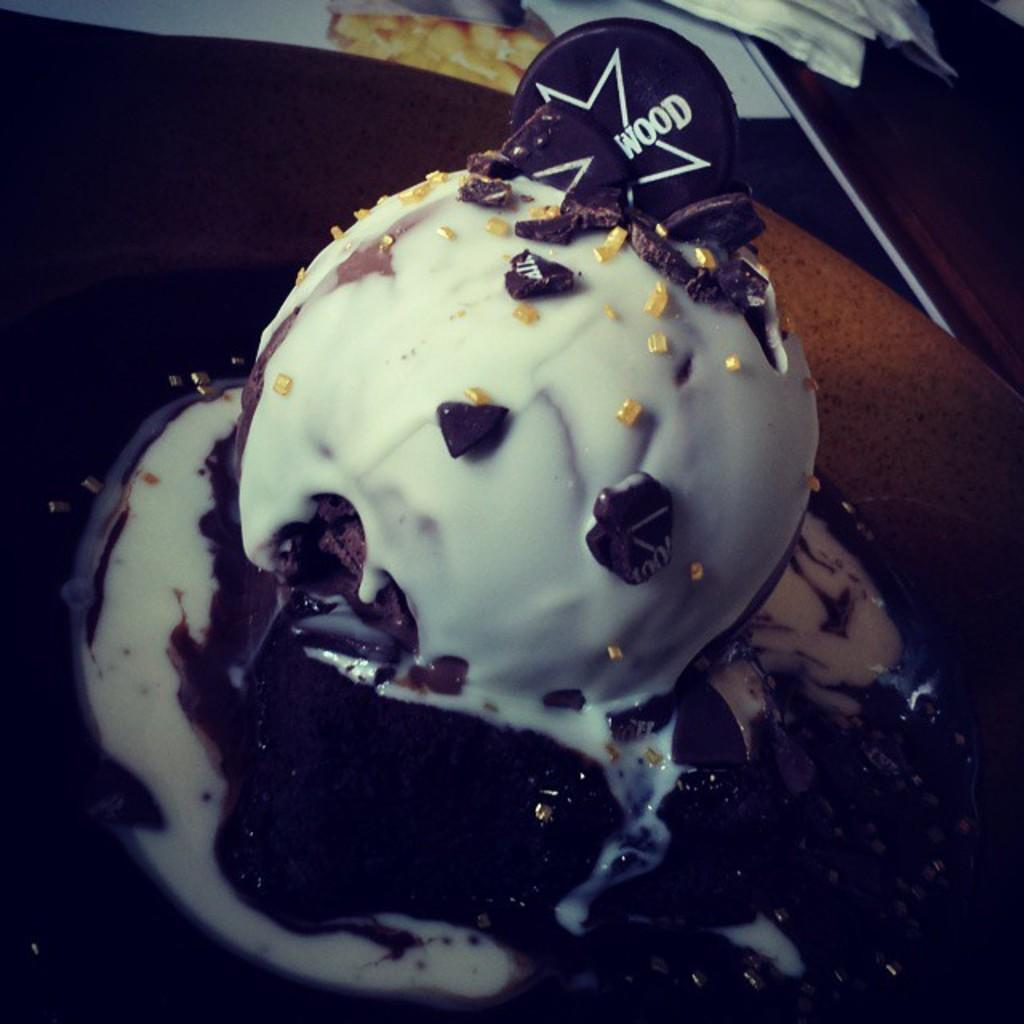What type of food item is visible in the image? There is a food item in the image, and it has chocolate topping. How is the food item presented in the image? The food item is on a plate in the image. Where is the plate with the food item located? The plate is placed on a table in the image. What does the son say to the dad about the crack in the food item? There is no son or dad present in the image, and there is no mention of a crack in the food item. 